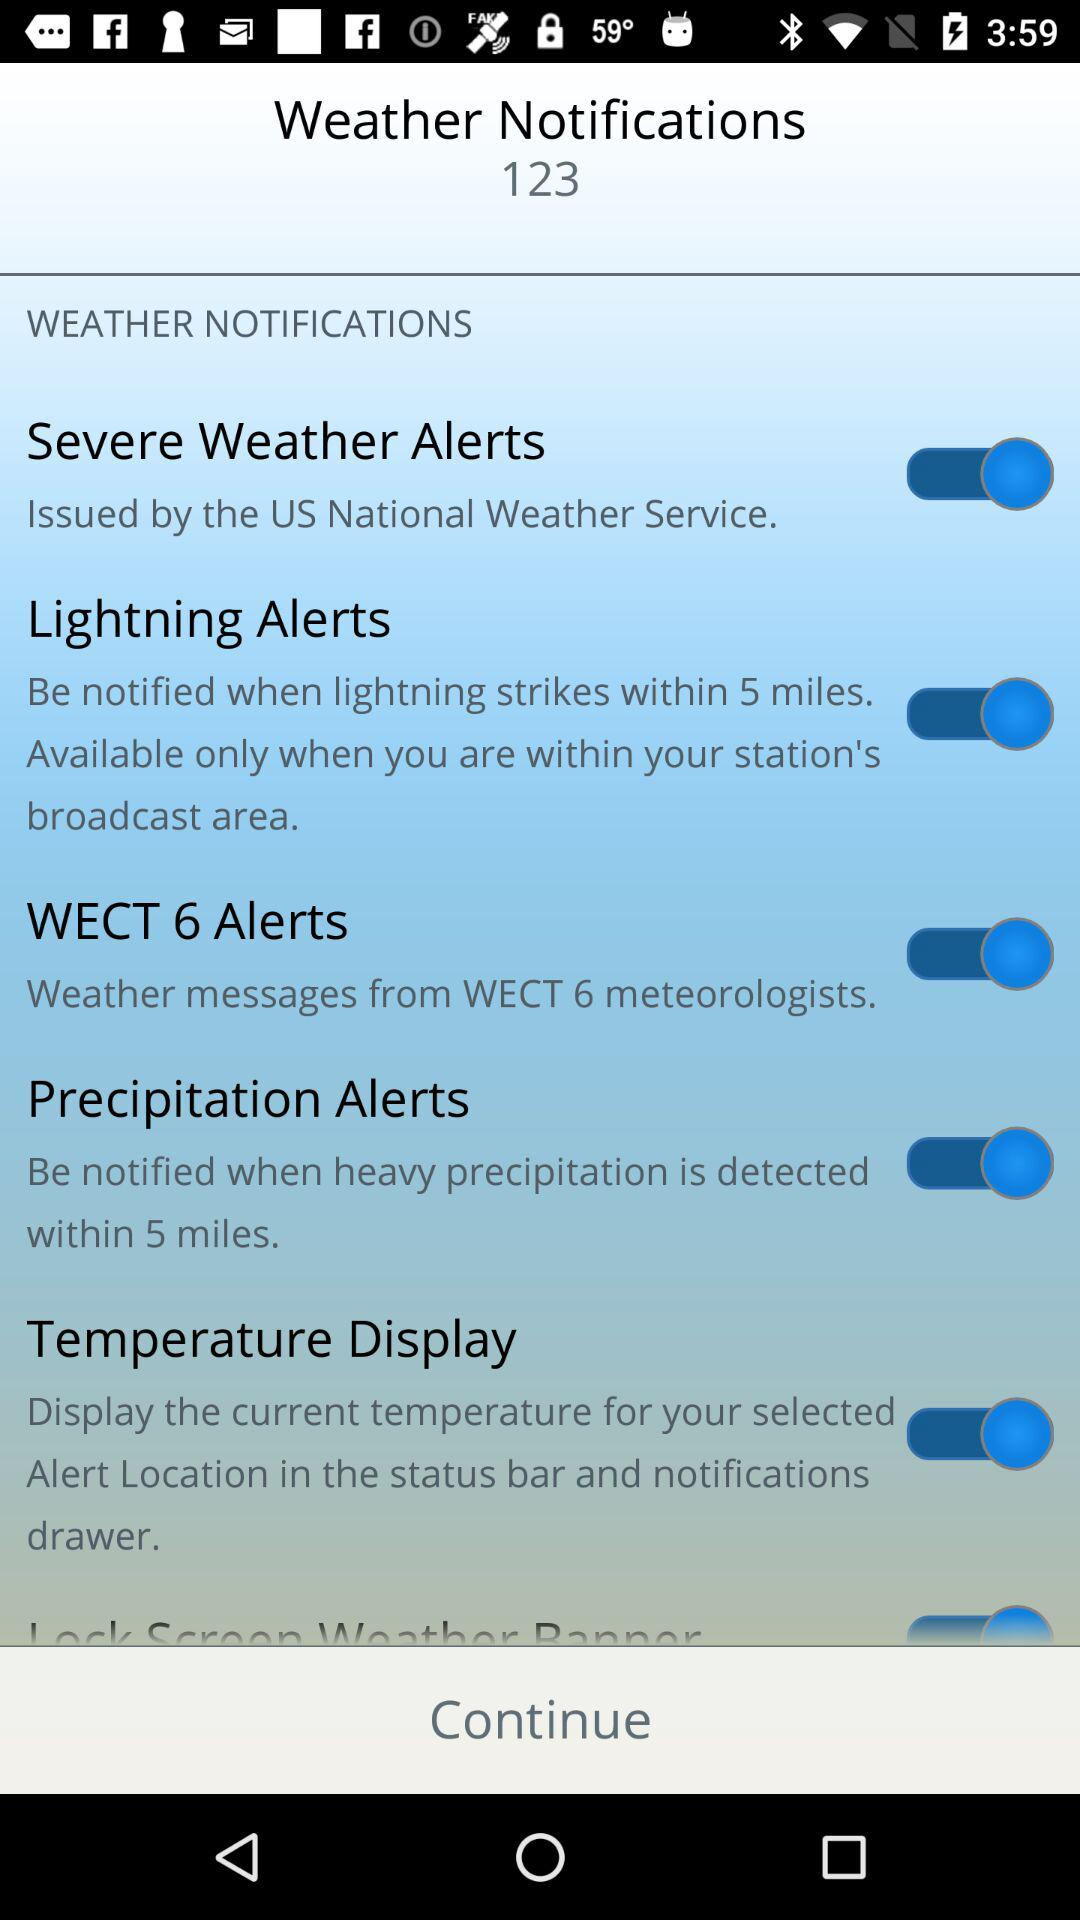What is the status of "Lightning Alerts"? The status is "on". 